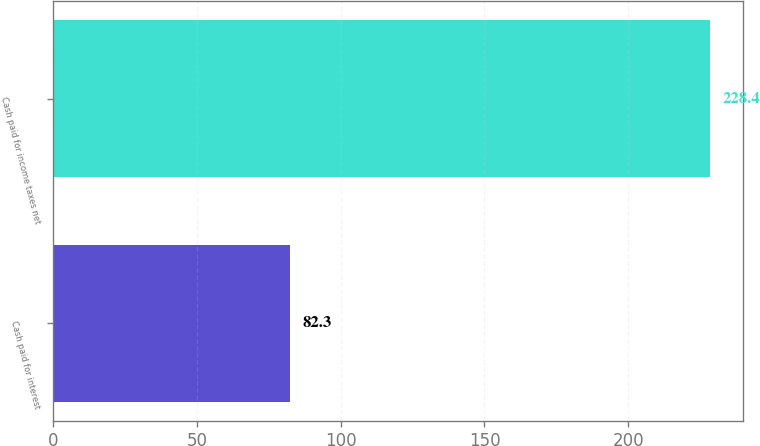Convert chart to OTSL. <chart><loc_0><loc_0><loc_500><loc_500><bar_chart><fcel>Cash paid for interest<fcel>Cash paid for income taxes net<nl><fcel>82.3<fcel>228.4<nl></chart> 